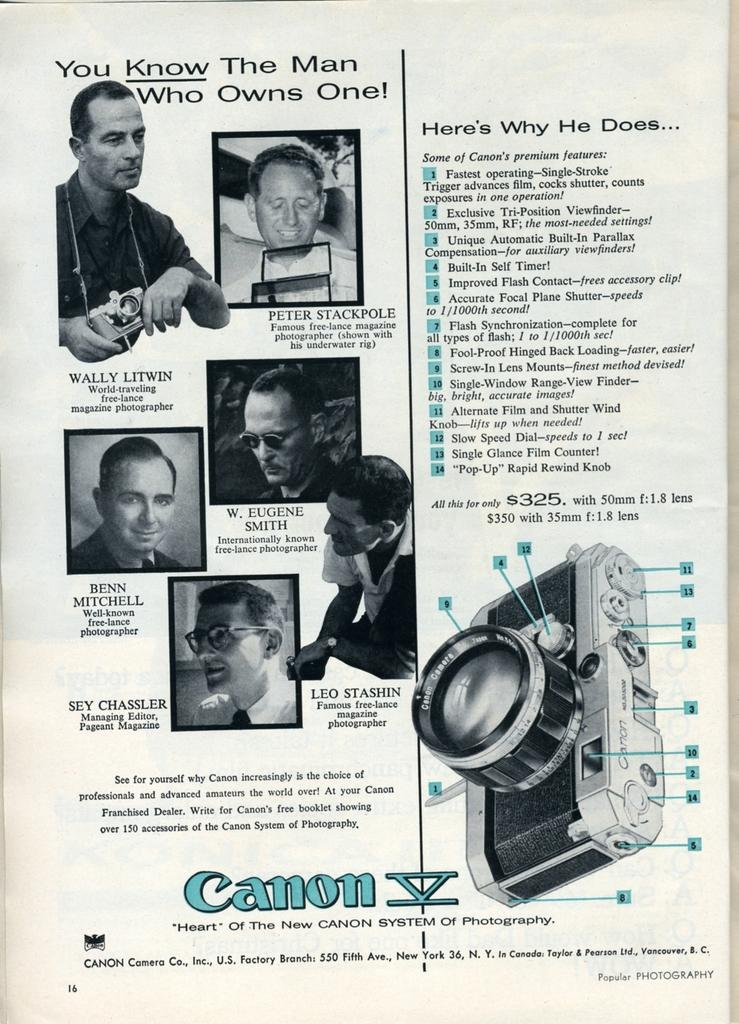What is present on the paper in the image? The paper has a print of humans on it. What else can be seen on the paper? There is text on the paper. What other object is visible in the image? There is a camera in the image. What type of mist can be seen surrounding the humans on the paper? There is no mist present in the image; the paper only shows a print of humans with text. 